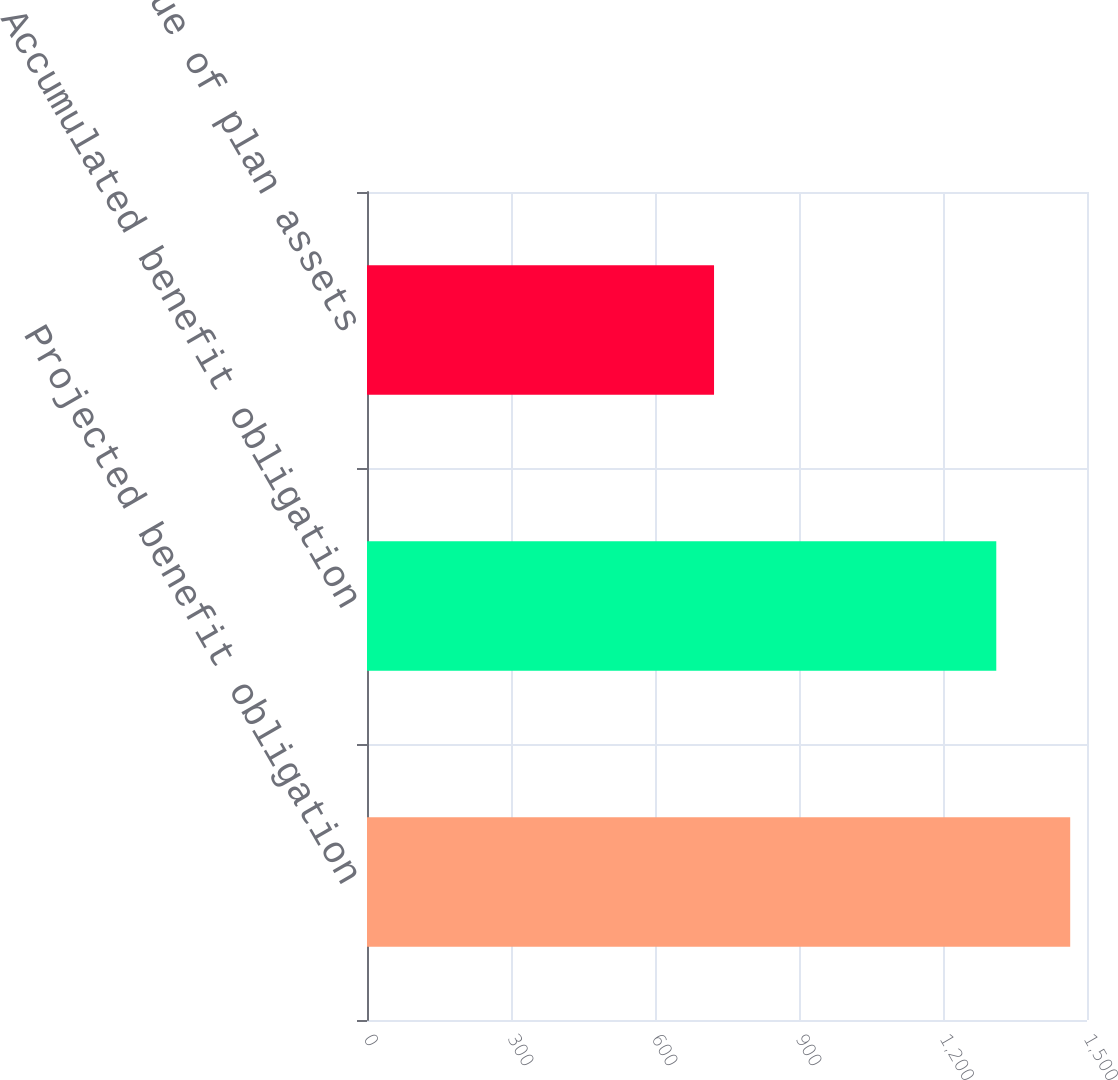<chart> <loc_0><loc_0><loc_500><loc_500><bar_chart><fcel>Projected benefit obligation<fcel>Accumulated benefit obligation<fcel>Fair value of plan assets<nl><fcel>1465<fcel>1311<fcel>723<nl></chart> 